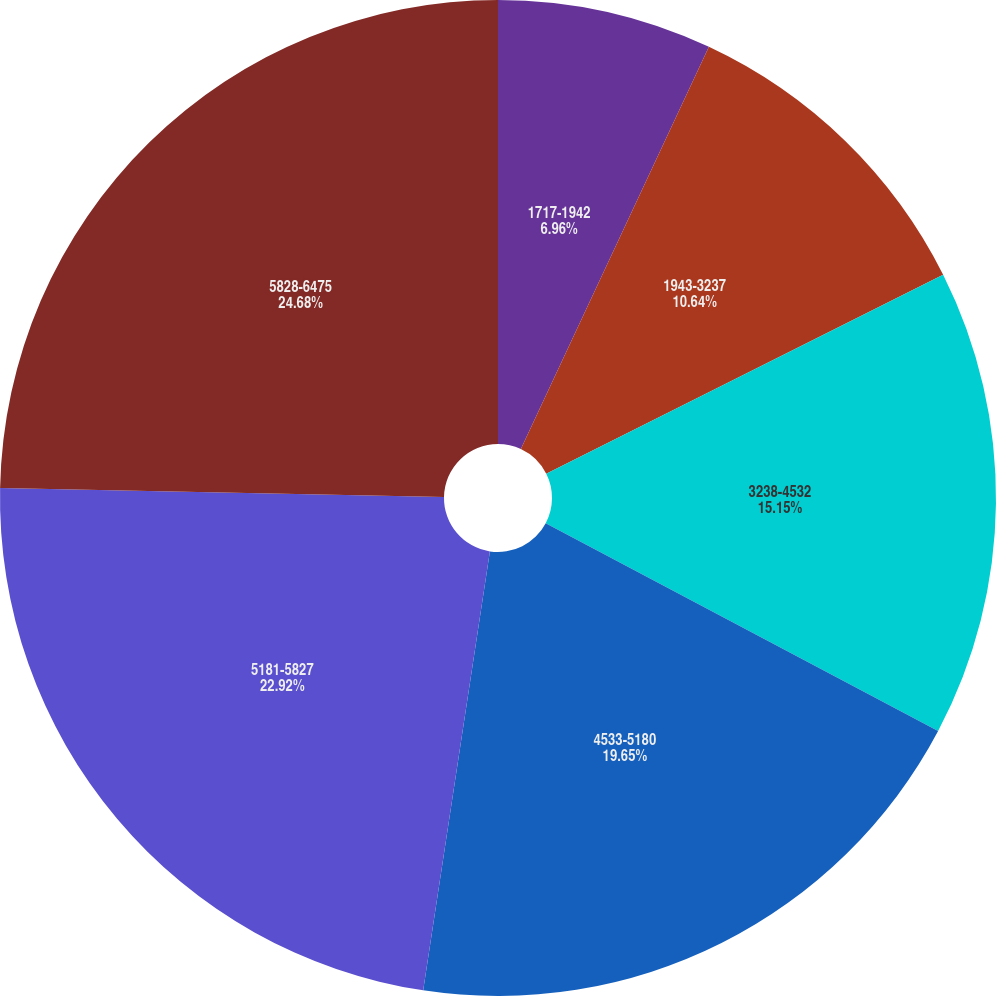<chart> <loc_0><loc_0><loc_500><loc_500><pie_chart><fcel>1717-1942<fcel>1943-3237<fcel>3238-4532<fcel>4533-5180<fcel>5181-5827<fcel>5828-6475<nl><fcel>6.96%<fcel>10.64%<fcel>15.15%<fcel>19.65%<fcel>22.92%<fcel>24.68%<nl></chart> 